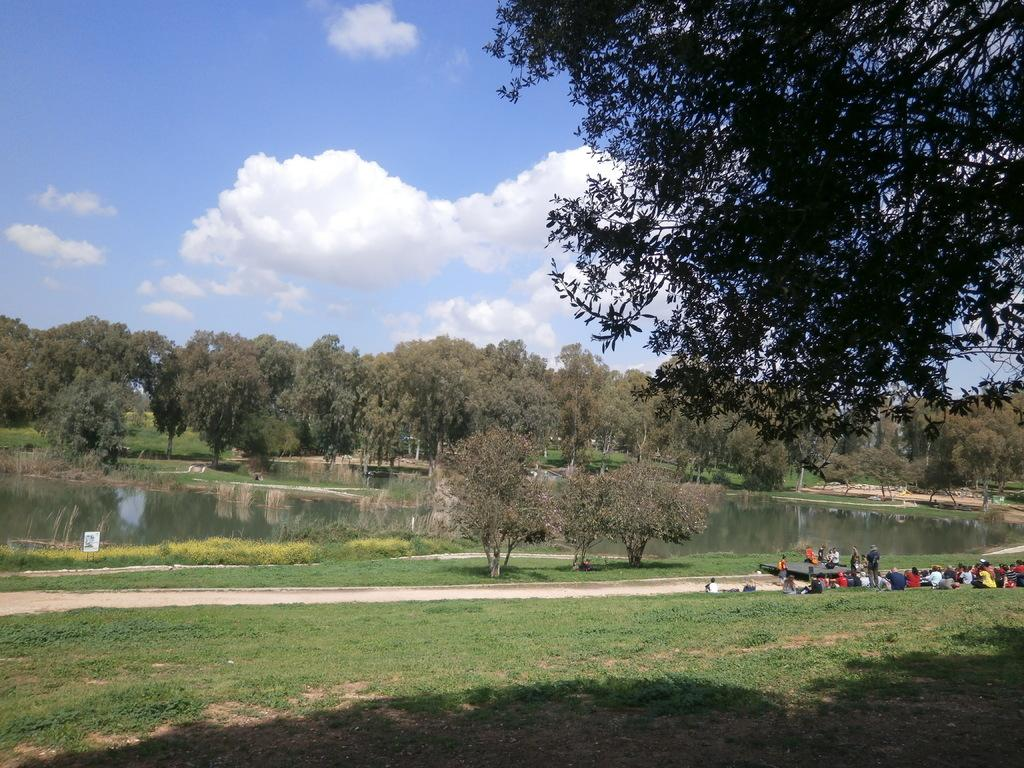What can be seen in the foreground of the picture? In the foreground of the picture, there are people, grass, soil, and a tree. What is located in the center of the picture? In the center of the picture, there are trees, a lake, plants, a path, and grass. How is the weather depicted in the image? The sky is cloudy, and it is sunny. Can you see a pocket in the image? There is no pocket present in the image. Are the people in the image kissing? The image does not depict any kissing between the people. 